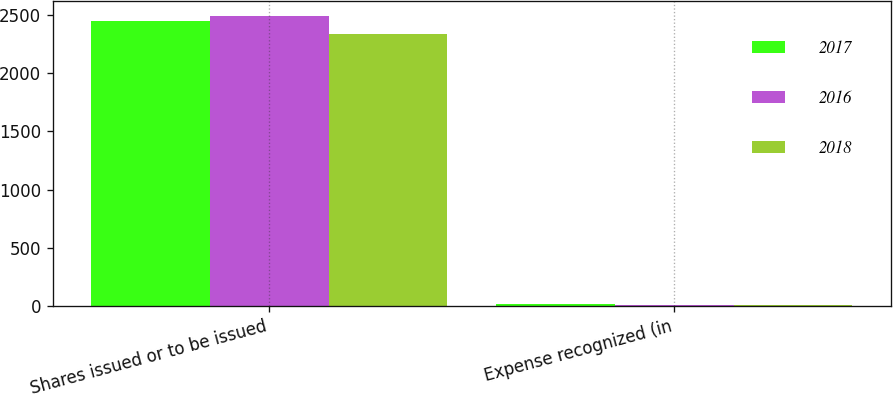<chart> <loc_0><loc_0><loc_500><loc_500><stacked_bar_chart><ecel><fcel>Shares issued or to be issued<fcel>Expense recognized (in<nl><fcel>2017<fcel>2452<fcel>17<nl><fcel>2016<fcel>2491<fcel>13<nl><fcel>2018<fcel>2337<fcel>11<nl></chart> 